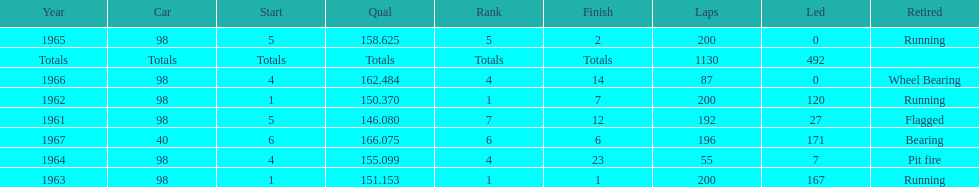How many total laps have been driven in the indy 500? 1130. 